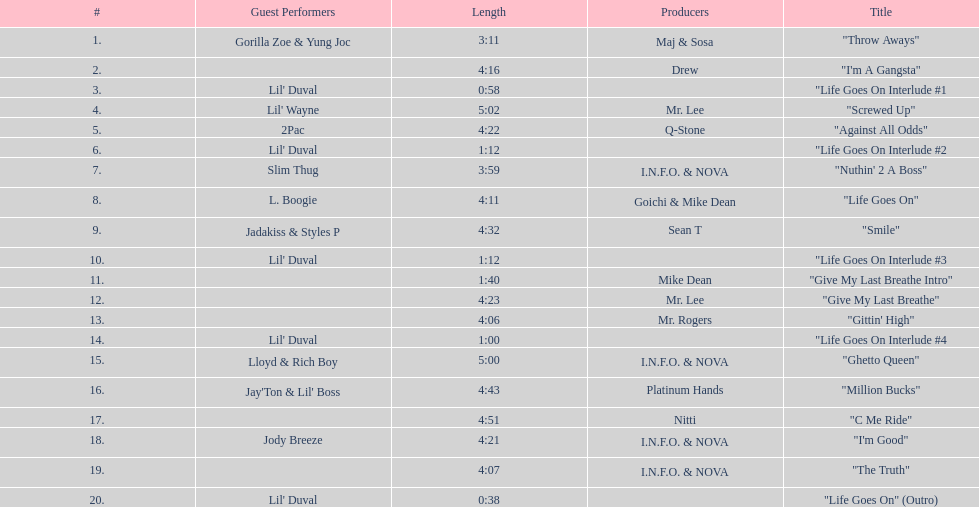What is the last track produced by mr. lee? "Give My Last Breathe". 